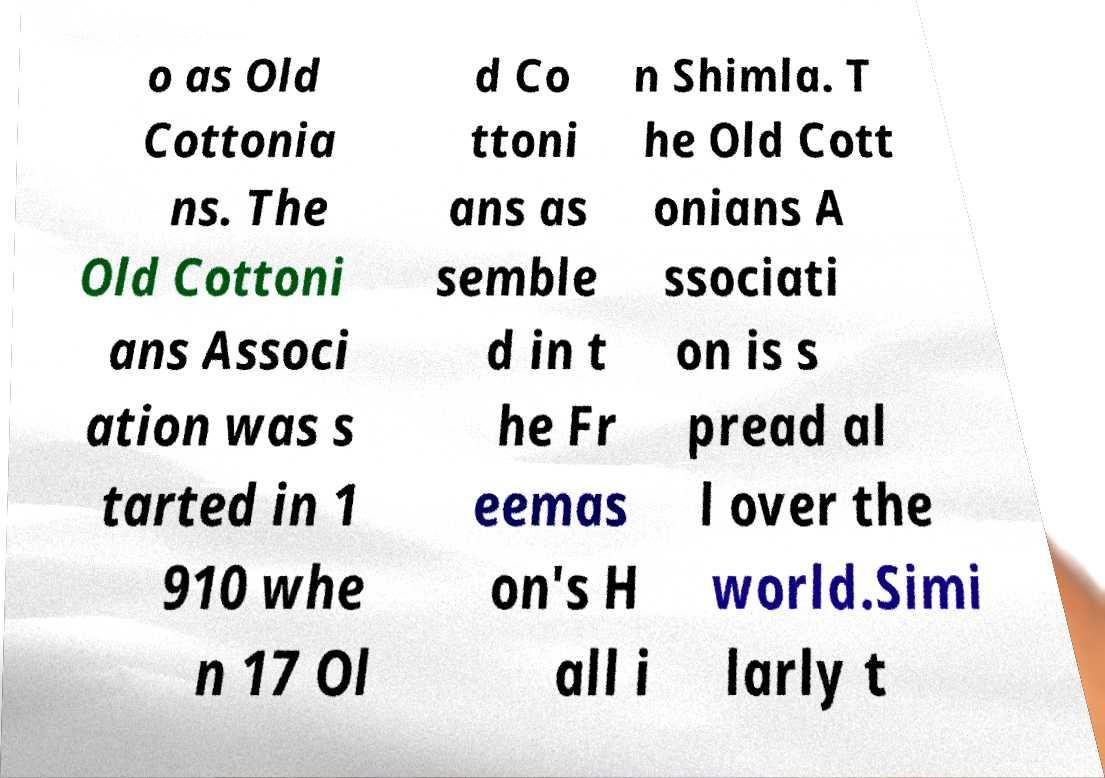Please identify and transcribe the text found in this image. o as Old Cottonia ns. The Old Cottoni ans Associ ation was s tarted in 1 910 whe n 17 Ol d Co ttoni ans as semble d in t he Fr eemas on's H all i n Shimla. T he Old Cott onians A ssociati on is s pread al l over the world.Simi larly t 